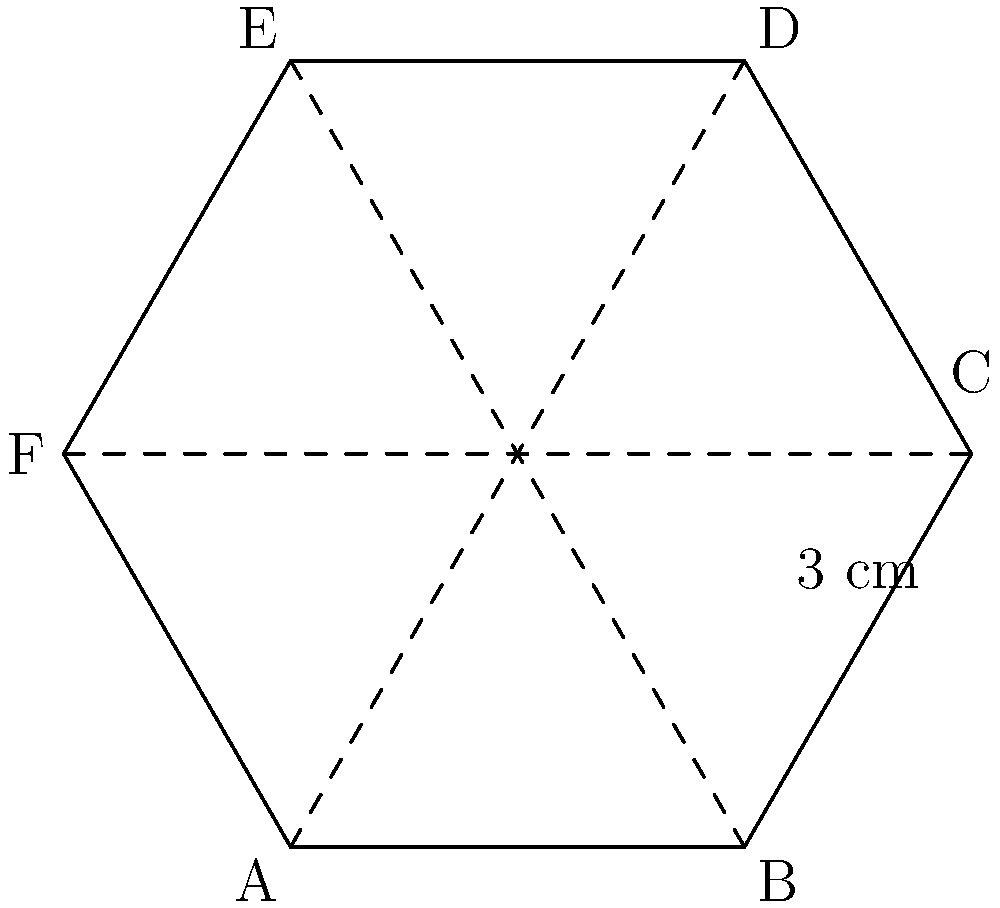As a nocturnal copywriter battling writer's block, you visualize your mental barrier as a hexagonal shape. If one side of this hexagonal writer's block measures 3 cm, what is its perimeter? To find the perimeter of the hexagonal writer's block, we need to follow these steps:

1. Recognize that a regular hexagon has 6 equal sides.
2. We are given that one side of the hexagon is 3 cm.
3. To calculate the perimeter, we need to multiply the length of one side by the number of sides.

Mathematically:
$$\text{Perimeter} = 6 \times \text{side length}$$
$$\text{Perimeter} = 6 \times 3 \text{ cm}$$
$$\text{Perimeter} = 18 \text{ cm}$$

Therefore, the perimeter of the hexagonal writer's block is 18 cm.
Answer: 18 cm 